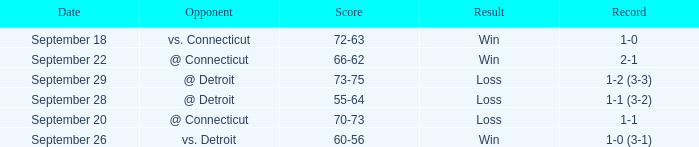WHAT IS THE SCORE WITH A RECORD OF 1-0? 72-63. 